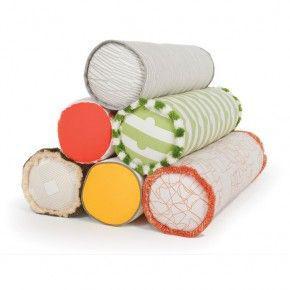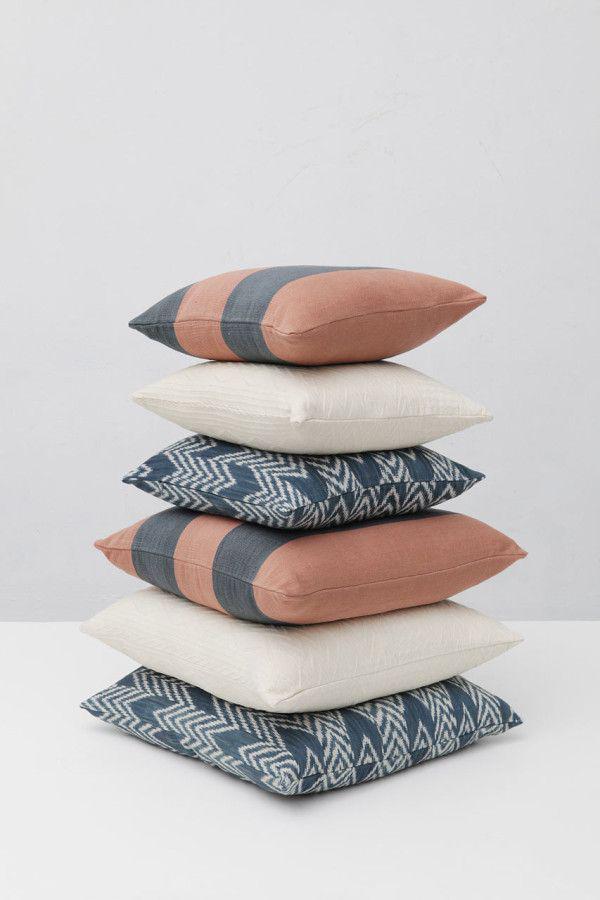The first image is the image on the left, the second image is the image on the right. Considering the images on both sides, is "In one of the images, there are exactly six square pillows stacked on top of each other." valid? Answer yes or no. Yes. 